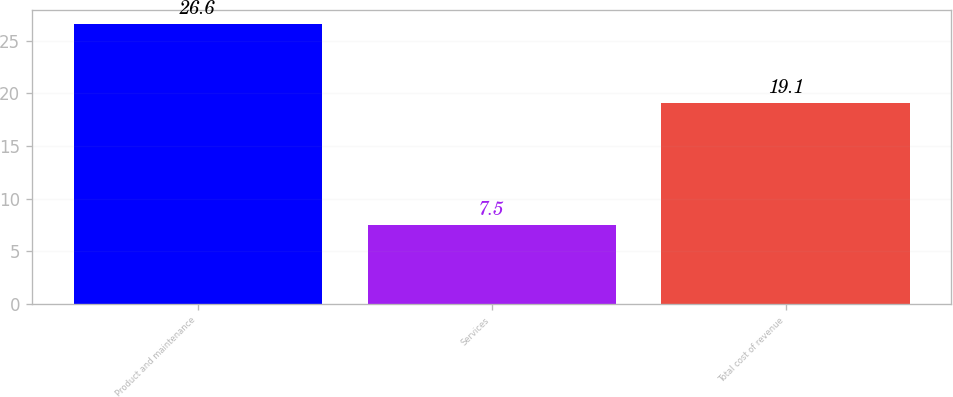<chart> <loc_0><loc_0><loc_500><loc_500><bar_chart><fcel>Product and maintenance<fcel>Services<fcel>Total cost of revenue<nl><fcel>26.6<fcel>7.5<fcel>19.1<nl></chart> 